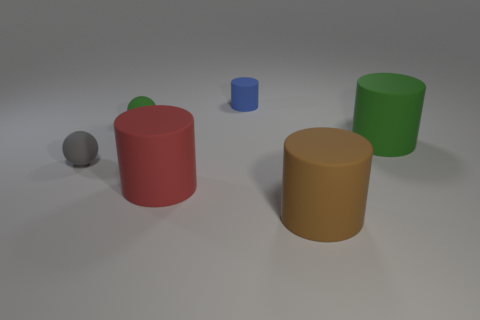What is the material of the green ball that is the same size as the blue cylinder?
Offer a very short reply. Rubber. What number of large things are behind the red matte object?
Provide a short and direct response. 1. There is a small thing right of the tiny green matte ball; is its shape the same as the small green object?
Give a very brief answer. No. Are there any big brown rubber objects that have the same shape as the red object?
Your response must be concise. Yes. There is a big rubber thing that is behind the object on the left side of the tiny green matte ball; what is its shape?
Ensure brevity in your answer.  Cylinder. What number of other green spheres are made of the same material as the tiny green ball?
Your response must be concise. 0. What color is the other tiny cylinder that is the same material as the brown cylinder?
Give a very brief answer. Blue. What size is the rubber ball that is behind the small sphere that is on the left side of the matte ball that is to the right of the gray sphere?
Keep it short and to the point. Small. Are there fewer small blue rubber objects than big gray shiny objects?
Keep it short and to the point. No. There is a tiny rubber object that is the same shape as the large red thing; what is its color?
Provide a short and direct response. Blue. 